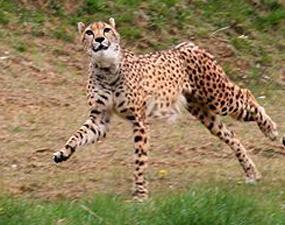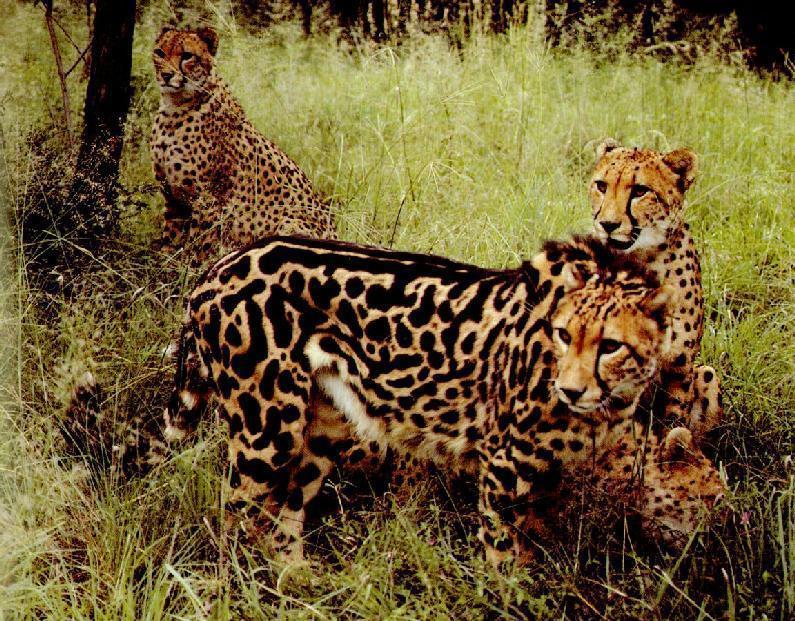The first image is the image on the left, the second image is the image on the right. Examine the images to the left and right. Is the description "There is a single cheetah pursuing a prey in the right image." accurate? Answer yes or no. No. The first image is the image on the left, the second image is the image on the right. Assess this claim about the two images: "In one image, a jaguar is hunting one single prey.". Correct or not? Answer yes or no. No. 